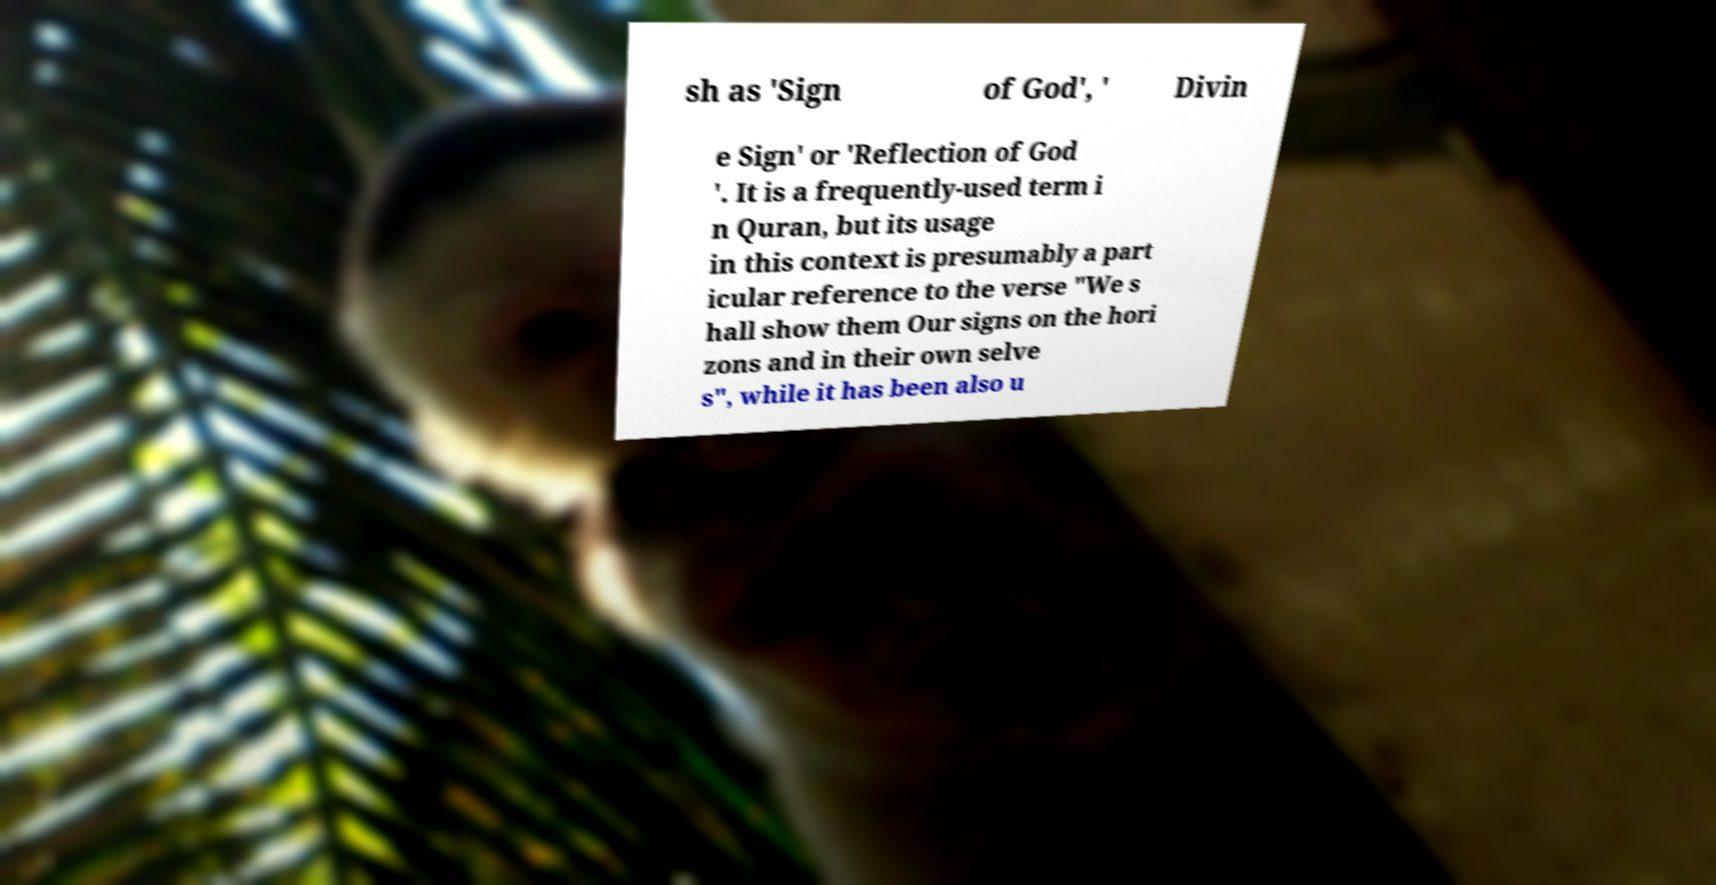Can you accurately transcribe the text from the provided image for me? sh as 'Sign of God', ' Divin e Sign' or 'Reflection of God '. It is a frequently-used term i n Quran, but its usage in this context is presumably a part icular reference to the verse "We s hall show them Our signs on the hori zons and in their own selve s", while it has been also u 